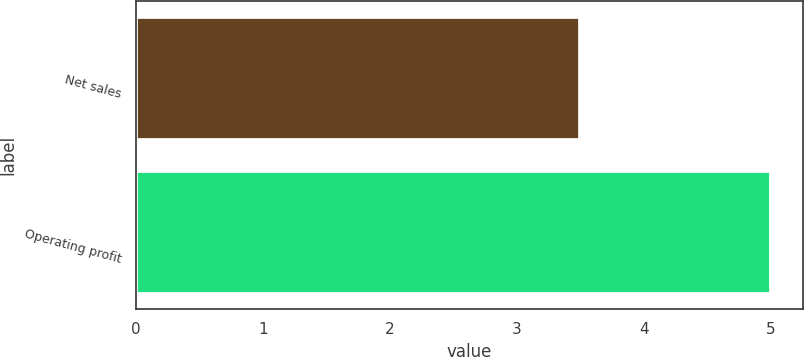Convert chart to OTSL. <chart><loc_0><loc_0><loc_500><loc_500><bar_chart><fcel>Net sales<fcel>Operating profit<nl><fcel>3.5<fcel>5<nl></chart> 